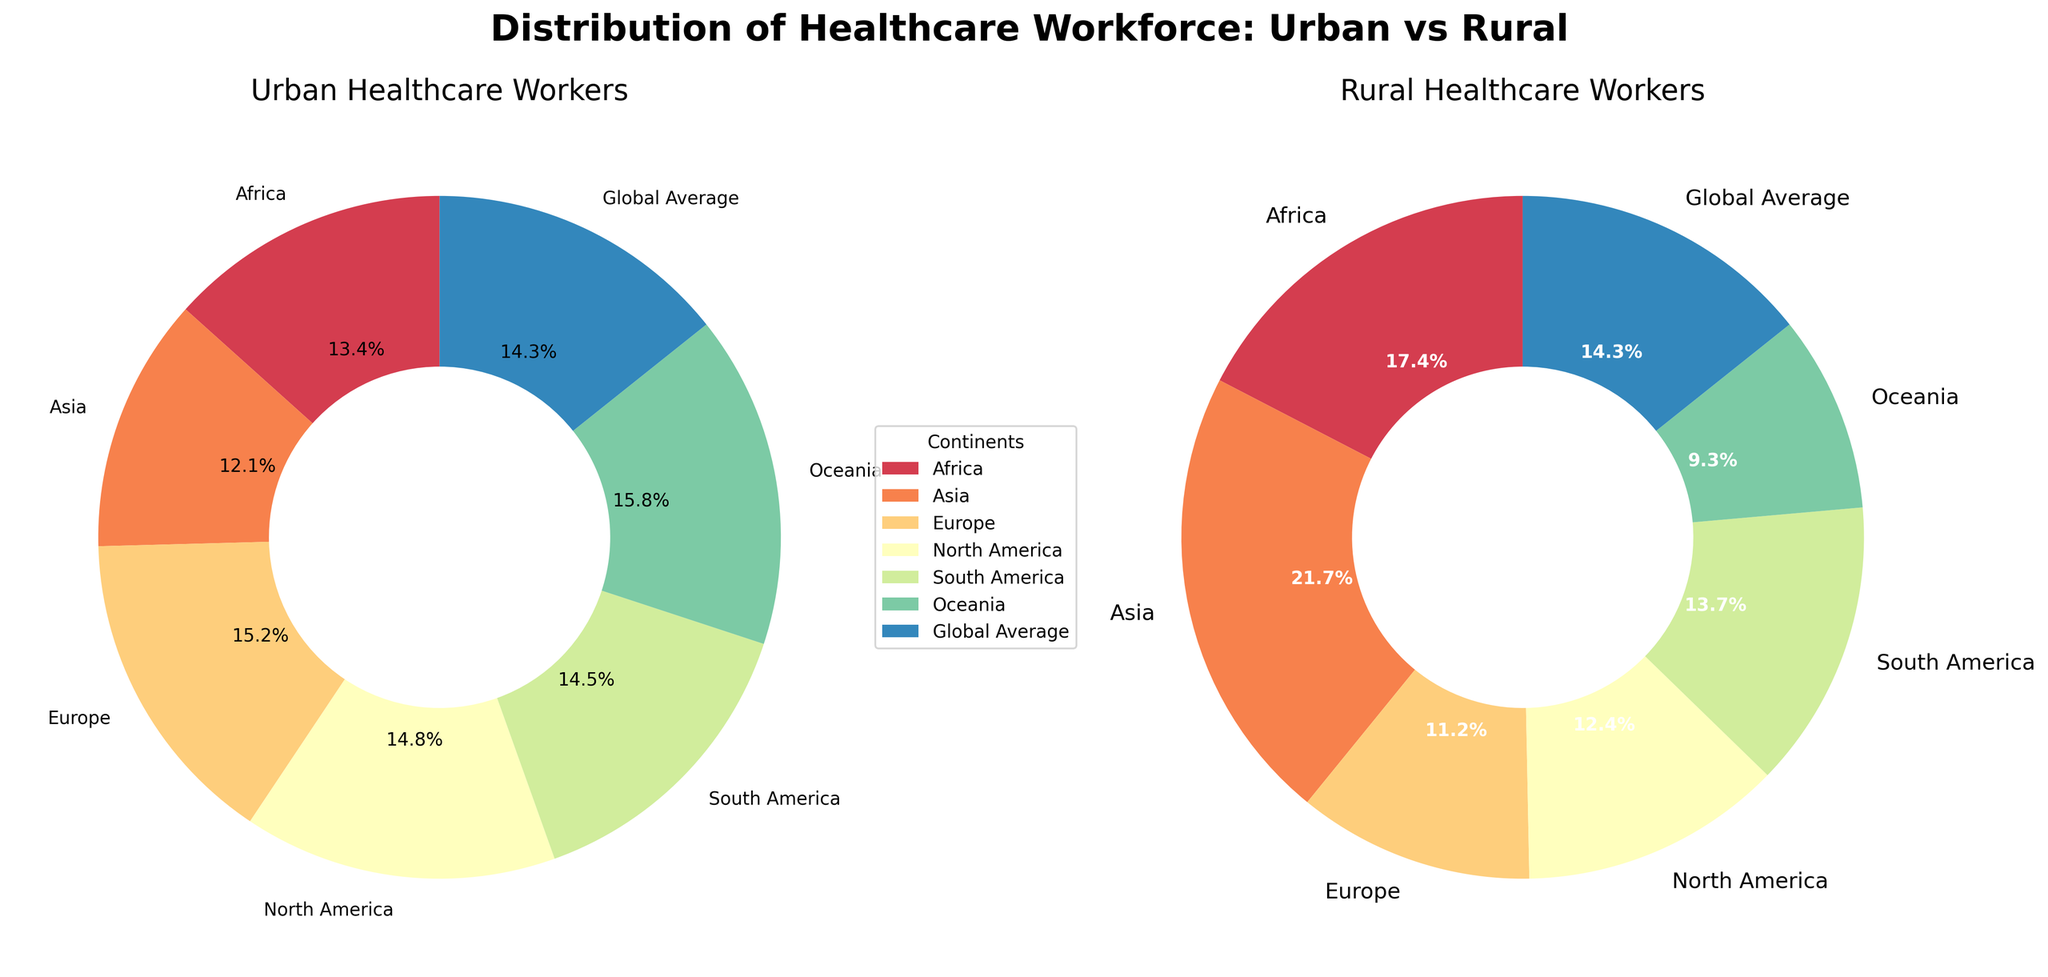Which continent has the highest percentage of urban healthcare workers? Observe the Urban Healthcare Workers pie chart and look for the largest wedge. Oceania has the highest percentage at 85%.
Answer: Oceania Which continent has the lowest percentage of rural healthcare workers? Observe the Rural Healthcare Workers pie chart and identify the smallest wedge. Oceania has the lowest percentage at 15%.
Answer: Oceania How does the percentage of urban healthcare workers in Europe compare to that in North America? Compare the wedges in the Urban Healthcare Workers pie chart for Europe and North America. Europe has 82%, and North America has 80%. Europe has a 2% higher percentage.
Answer: Europe has a higher percentage Which continent has a closer distribution between urban and rural healthcare workers? Compare the percentages of urban and rural healthcare workers in each continent. Asia has the most balanced distribution with 65% urban and 35% rural.
Answer: Asia What’s the combined percentage of rural healthcare workers in Africa and Asia? Sum the percentages of Rural Healthcare Workers in Africa (28%) and Asia (35%). 28 + 35 = 63%.
Answer: 63% Which continents have their urban healthcare workers' percentage higher than the global average? Compare the urban percentages of each continent with the global average which is 77%. Europe (82%), North America (80%), South America (78%), and Oceania (85%) are all higher than the global average.
Answer: Europe, North America, South America, Oceania What is the difference in the percentage of urban healthcare workers between South America and Africa? Subtract the percentage of urban healthcare workers in South America (78%) and Africa (72%). 78 - 72 = 6%.
Answer: 6% Which continent shows the largest discrepancy between urban and rural healthcare workers? Identify the continent with the greatest difference between its urban and rural percentages. Oceania has 85% urban and 15% rural, a difference of 70%.
Answer: Oceania 